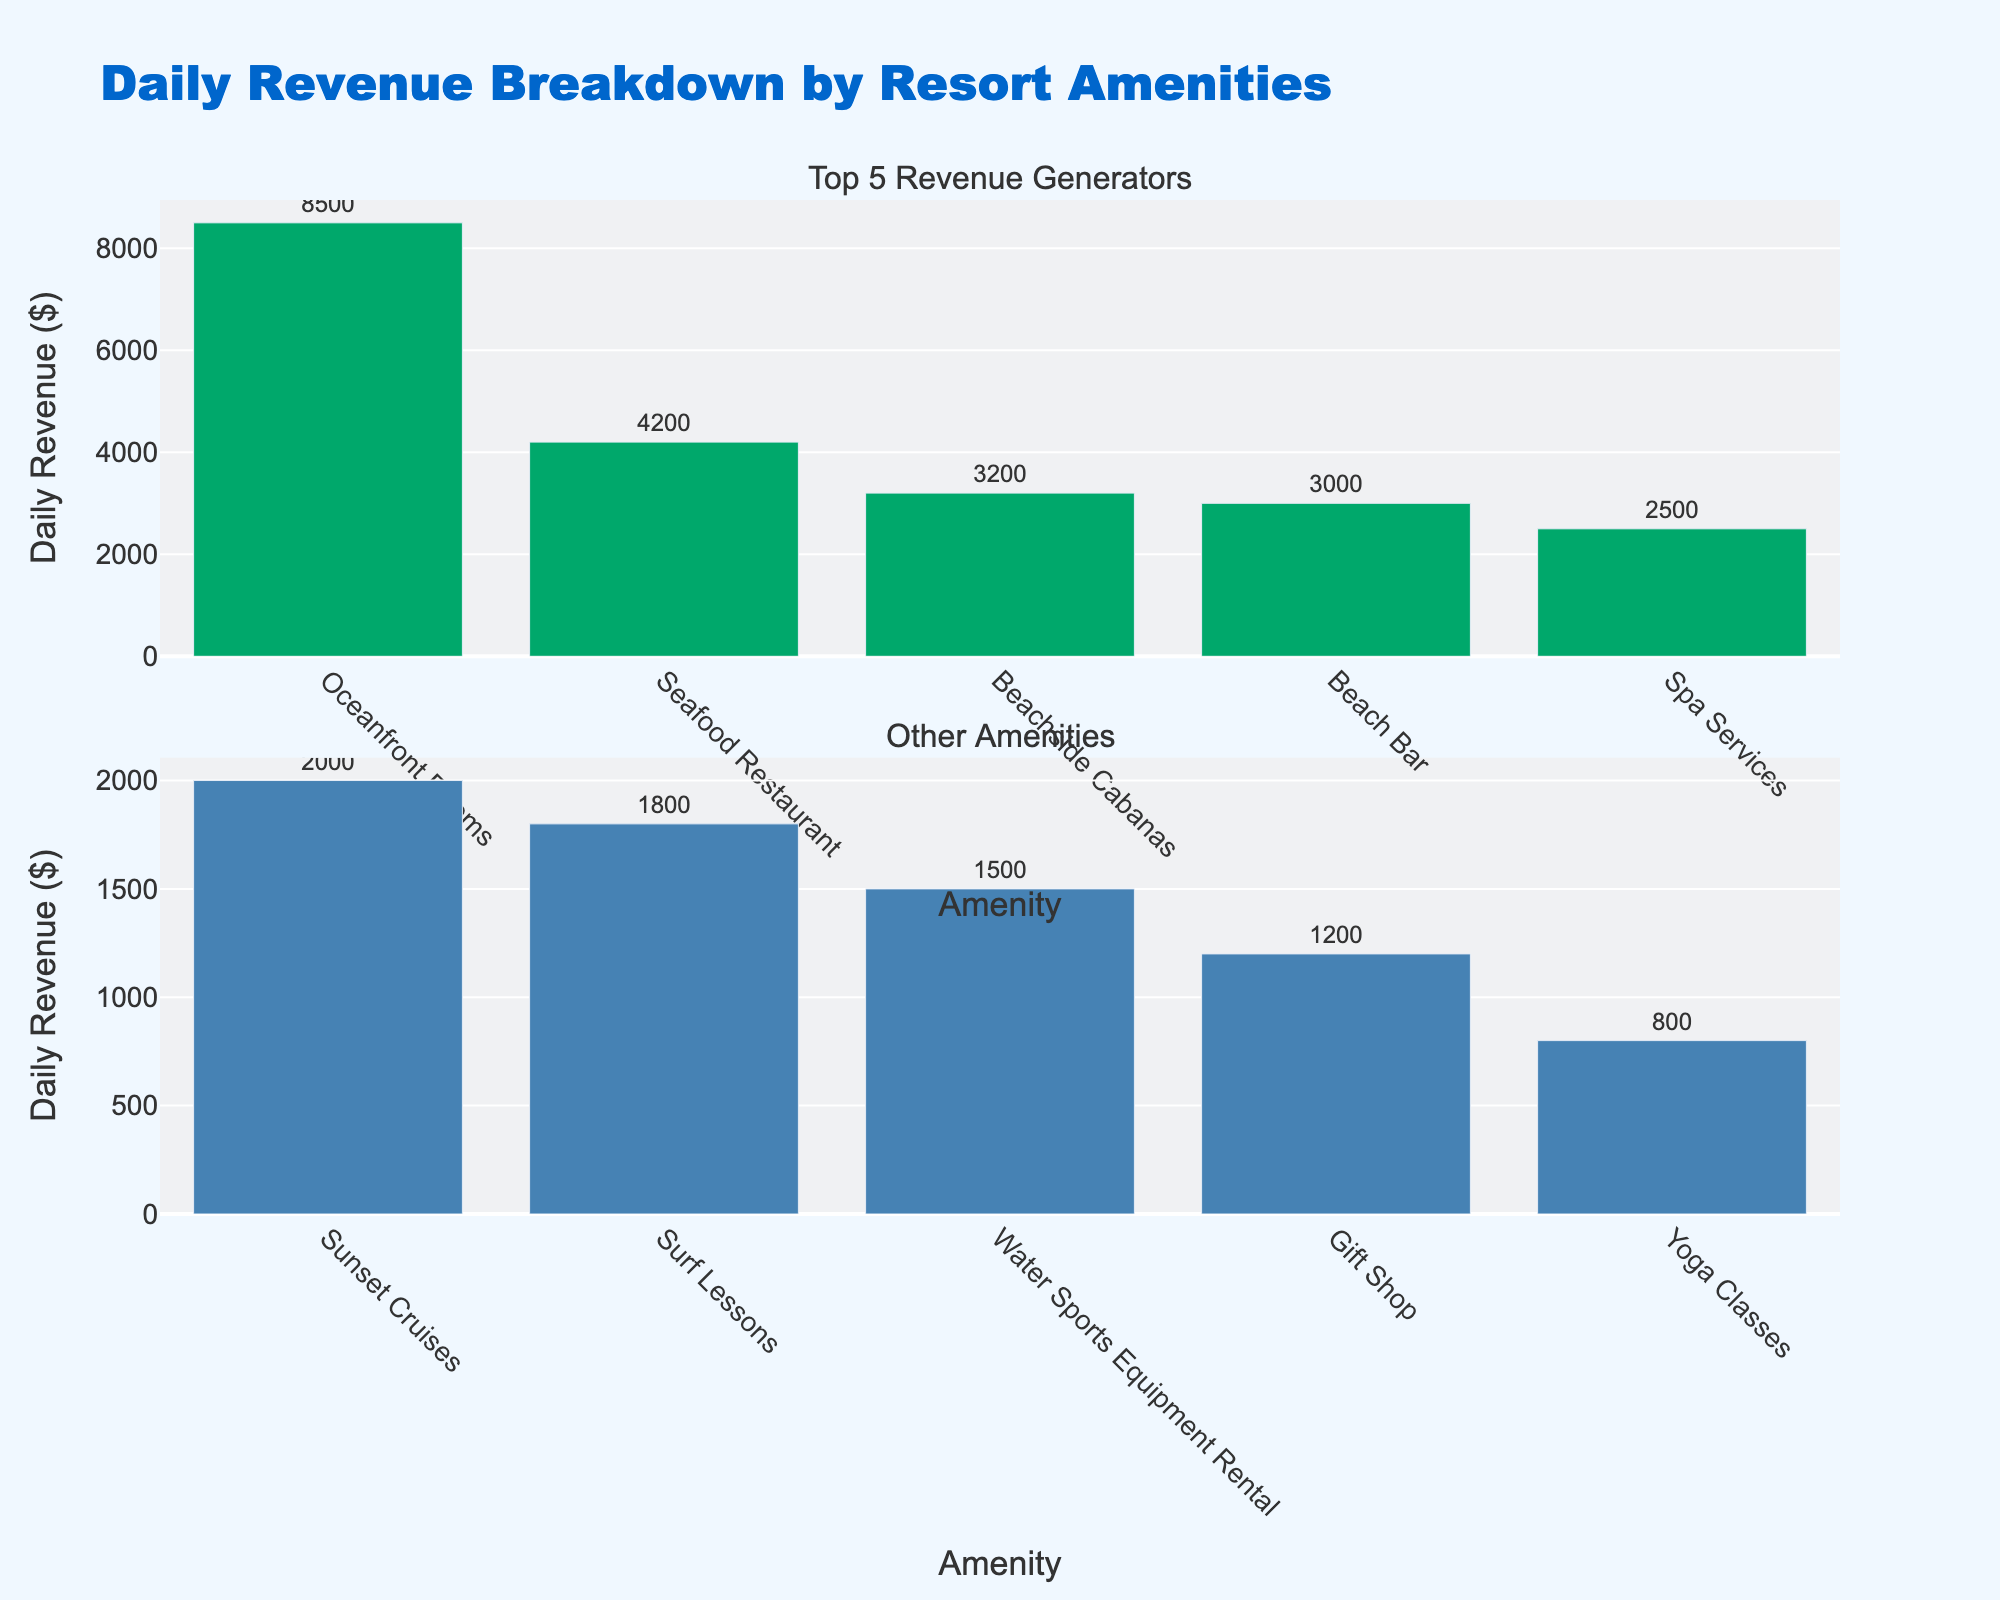what is the main title of the figure? The title of the figure is located at the top of the plot and is usually larger in font size and darker in color compared to other texts. It gives a brief description of what the figure is about.
Answer: Screening Methods Comparison Matrix How many screening methods are represented in the figure? The number of screening methods can be identified by counting the distinct data points or markers in the scatter plots and histograms, which are labeled with the screening methods.
Answer: 10 Which screening method has the highest detection rate? The screening methods are represented by data points in the scatter plots, with the detection rate on the y-axis in several plots. The screening method with the data point at the highest value on the detection rate axis has the highest detection rate.
Answer: Genetic_Testing What is the relationship between cost per test and patient comfort score? By looking at the scatter plot where cost per test is on the x-axis and patient comfort score is on the y-axis, we can observe the trend of data points to determine if there's a relationship.
Answer: Generally inverse relationship Among the screening methods, which has the highest cost per test and what is its detection rate? By observing the scatter plot where the cost per test is plotted on the x-axis, identify the screening method with the farthest data point to the right. Then, check the detection rate in the corresponding scatter plot.
Answer: Genetic_Testing with 98 Is there a screening method that has both a low false positive rate and a high patient comfort score? Find the scatter plot where false positive rate is on the x-axis and patient comfort score is on the y-axis. Look for data points that are close to the left side (low false positive rate) and top (high patient comfort score).
Answer: Clinical_Breast_Exam Which screening method has the highest patient comfort score and how does it compare in detection rate? Find the scatter plot where patient comfort score is on the y-axis and identify the highest point. Check the corresponding detection rate in the detection rate scatter plot.
Answer: Clinical_Breast_Exam with 50 What trend can you observe between detection rate and false positive rate? Analyze scatter plots where detection rate is on the y-axis and false positive rate is on the x-axis, and observe whether data points indicate a positive, negative, or no apparent trend.
Answer: Slight positive trend Which screening method has the lowest comfort score and what are its cost and detection rate? Identify the data point at the lowest value on the patient comfort score axis in the relevant scatter plots. Then check the corresponding cost per test and detection rate in the respective plots.
Answer: Colonoscopy with cost 800 and detection rate 92 